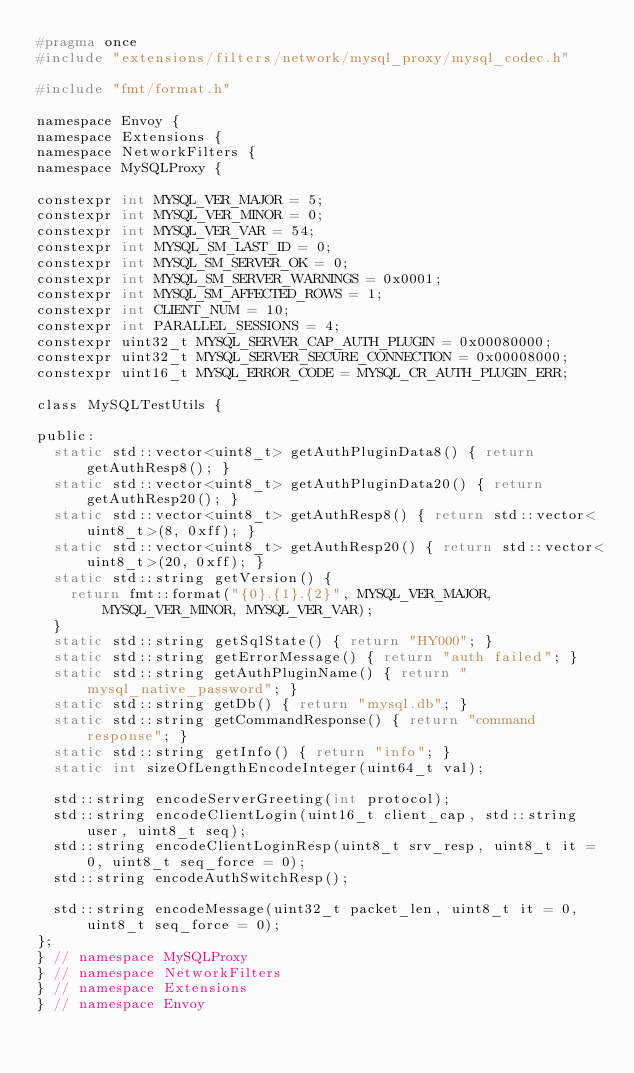Convert code to text. <code><loc_0><loc_0><loc_500><loc_500><_C_>#pragma once
#include "extensions/filters/network/mysql_proxy/mysql_codec.h"

#include "fmt/format.h"

namespace Envoy {
namespace Extensions {
namespace NetworkFilters {
namespace MySQLProxy {

constexpr int MYSQL_VER_MAJOR = 5;
constexpr int MYSQL_VER_MINOR = 0;
constexpr int MYSQL_VER_VAR = 54;
constexpr int MYSQL_SM_LAST_ID = 0;
constexpr int MYSQL_SM_SERVER_OK = 0;
constexpr int MYSQL_SM_SERVER_WARNINGS = 0x0001;
constexpr int MYSQL_SM_AFFECTED_ROWS = 1;
constexpr int CLIENT_NUM = 10;
constexpr int PARALLEL_SESSIONS = 4;
constexpr uint32_t MYSQL_SERVER_CAP_AUTH_PLUGIN = 0x00080000;
constexpr uint32_t MYSQL_SERVER_SECURE_CONNECTION = 0x00008000;
constexpr uint16_t MYSQL_ERROR_CODE = MYSQL_CR_AUTH_PLUGIN_ERR;

class MySQLTestUtils {

public:
  static std::vector<uint8_t> getAuthPluginData8() { return getAuthResp8(); }
  static std::vector<uint8_t> getAuthPluginData20() { return getAuthResp20(); }
  static std::vector<uint8_t> getAuthResp8() { return std::vector<uint8_t>(8, 0xff); }
  static std::vector<uint8_t> getAuthResp20() { return std::vector<uint8_t>(20, 0xff); }
  static std::string getVersion() {
    return fmt::format("{0}.{1}.{2}", MYSQL_VER_MAJOR, MYSQL_VER_MINOR, MYSQL_VER_VAR);
  }
  static std::string getSqlState() { return "HY000"; }
  static std::string getErrorMessage() { return "auth failed"; }
  static std::string getAuthPluginName() { return "mysql_native_password"; }
  static std::string getDb() { return "mysql.db"; }
  static std::string getCommandResponse() { return "command response"; }
  static std::string getInfo() { return "info"; }
  static int sizeOfLengthEncodeInteger(uint64_t val);

  std::string encodeServerGreeting(int protocol);
  std::string encodeClientLogin(uint16_t client_cap, std::string user, uint8_t seq);
  std::string encodeClientLoginResp(uint8_t srv_resp, uint8_t it = 0, uint8_t seq_force = 0);
  std::string encodeAuthSwitchResp();

  std::string encodeMessage(uint32_t packet_len, uint8_t it = 0, uint8_t seq_force = 0);
};
} // namespace MySQLProxy
} // namespace NetworkFilters
} // namespace Extensions
} // namespace Envoy
</code> 